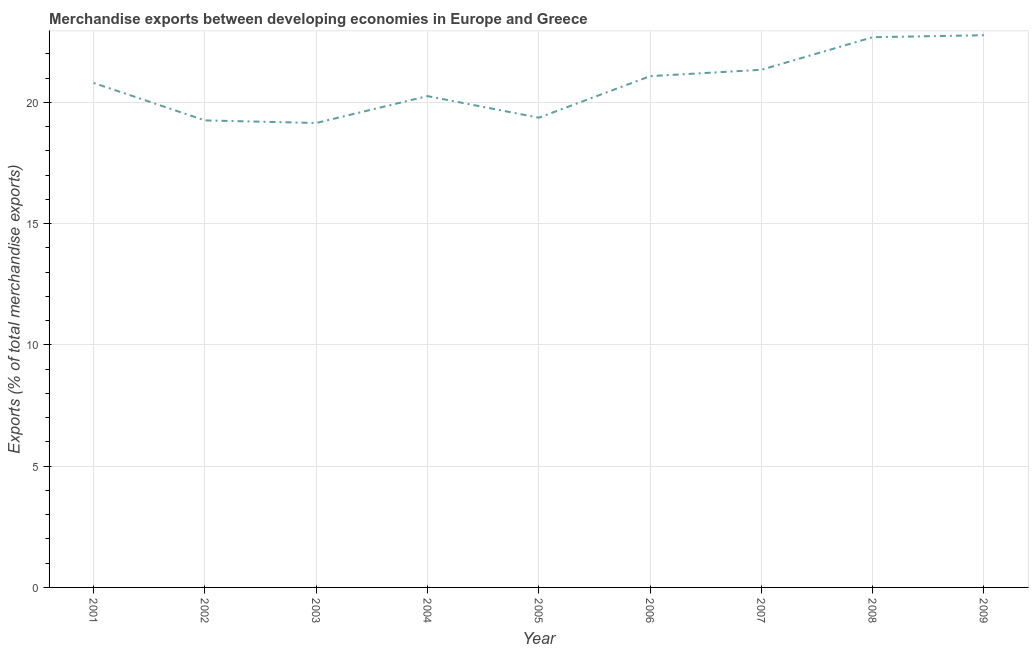What is the merchandise exports in 2008?
Keep it short and to the point. 22.68. Across all years, what is the maximum merchandise exports?
Offer a terse response. 22.77. Across all years, what is the minimum merchandise exports?
Offer a very short reply. 19.15. In which year was the merchandise exports minimum?
Ensure brevity in your answer.  2003. What is the sum of the merchandise exports?
Ensure brevity in your answer.  186.68. What is the difference between the merchandise exports in 2004 and 2009?
Your answer should be compact. -2.51. What is the average merchandise exports per year?
Keep it short and to the point. 20.74. What is the median merchandise exports?
Offer a very short reply. 20.8. In how many years, is the merchandise exports greater than 4 %?
Provide a short and direct response. 9. What is the ratio of the merchandise exports in 2005 to that in 2008?
Your answer should be compact. 0.85. Is the merchandise exports in 2006 less than that in 2009?
Provide a short and direct response. Yes. What is the difference between the highest and the second highest merchandise exports?
Provide a short and direct response. 0.08. What is the difference between the highest and the lowest merchandise exports?
Your response must be concise. 3.62. Does the merchandise exports monotonically increase over the years?
Provide a short and direct response. No. How many years are there in the graph?
Offer a very short reply. 9. Does the graph contain any zero values?
Ensure brevity in your answer.  No. Does the graph contain grids?
Ensure brevity in your answer.  Yes. What is the title of the graph?
Ensure brevity in your answer.  Merchandise exports between developing economies in Europe and Greece. What is the label or title of the Y-axis?
Keep it short and to the point. Exports (% of total merchandise exports). What is the Exports (% of total merchandise exports) in 2001?
Provide a succinct answer. 20.8. What is the Exports (% of total merchandise exports) in 2002?
Provide a short and direct response. 19.25. What is the Exports (% of total merchandise exports) in 2003?
Offer a very short reply. 19.15. What is the Exports (% of total merchandise exports) in 2004?
Your response must be concise. 20.25. What is the Exports (% of total merchandise exports) in 2005?
Offer a terse response. 19.36. What is the Exports (% of total merchandise exports) in 2006?
Offer a terse response. 21.08. What is the Exports (% of total merchandise exports) in 2007?
Provide a succinct answer. 21.34. What is the Exports (% of total merchandise exports) of 2008?
Offer a very short reply. 22.68. What is the Exports (% of total merchandise exports) of 2009?
Your answer should be very brief. 22.77. What is the difference between the Exports (% of total merchandise exports) in 2001 and 2002?
Offer a very short reply. 1.54. What is the difference between the Exports (% of total merchandise exports) in 2001 and 2003?
Offer a very short reply. 1.65. What is the difference between the Exports (% of total merchandise exports) in 2001 and 2004?
Provide a short and direct response. 0.54. What is the difference between the Exports (% of total merchandise exports) in 2001 and 2005?
Give a very brief answer. 1.43. What is the difference between the Exports (% of total merchandise exports) in 2001 and 2006?
Keep it short and to the point. -0.28. What is the difference between the Exports (% of total merchandise exports) in 2001 and 2007?
Keep it short and to the point. -0.54. What is the difference between the Exports (% of total merchandise exports) in 2001 and 2008?
Make the answer very short. -1.88. What is the difference between the Exports (% of total merchandise exports) in 2001 and 2009?
Your answer should be very brief. -1.97. What is the difference between the Exports (% of total merchandise exports) in 2002 and 2003?
Your response must be concise. 0.11. What is the difference between the Exports (% of total merchandise exports) in 2002 and 2004?
Offer a very short reply. -1. What is the difference between the Exports (% of total merchandise exports) in 2002 and 2005?
Keep it short and to the point. -0.11. What is the difference between the Exports (% of total merchandise exports) in 2002 and 2006?
Provide a succinct answer. -1.82. What is the difference between the Exports (% of total merchandise exports) in 2002 and 2007?
Your answer should be compact. -2.09. What is the difference between the Exports (% of total merchandise exports) in 2002 and 2008?
Make the answer very short. -3.43. What is the difference between the Exports (% of total merchandise exports) in 2002 and 2009?
Ensure brevity in your answer.  -3.51. What is the difference between the Exports (% of total merchandise exports) in 2003 and 2004?
Your answer should be compact. -1.11. What is the difference between the Exports (% of total merchandise exports) in 2003 and 2005?
Provide a succinct answer. -0.22. What is the difference between the Exports (% of total merchandise exports) in 2003 and 2006?
Provide a short and direct response. -1.93. What is the difference between the Exports (% of total merchandise exports) in 2003 and 2007?
Provide a succinct answer. -2.19. What is the difference between the Exports (% of total merchandise exports) in 2003 and 2008?
Provide a short and direct response. -3.54. What is the difference between the Exports (% of total merchandise exports) in 2003 and 2009?
Make the answer very short. -3.62. What is the difference between the Exports (% of total merchandise exports) in 2004 and 2005?
Your answer should be compact. 0.89. What is the difference between the Exports (% of total merchandise exports) in 2004 and 2006?
Keep it short and to the point. -0.82. What is the difference between the Exports (% of total merchandise exports) in 2004 and 2007?
Your answer should be very brief. -1.09. What is the difference between the Exports (% of total merchandise exports) in 2004 and 2008?
Keep it short and to the point. -2.43. What is the difference between the Exports (% of total merchandise exports) in 2004 and 2009?
Offer a terse response. -2.51. What is the difference between the Exports (% of total merchandise exports) in 2005 and 2006?
Keep it short and to the point. -1.71. What is the difference between the Exports (% of total merchandise exports) in 2005 and 2007?
Your answer should be compact. -1.98. What is the difference between the Exports (% of total merchandise exports) in 2005 and 2008?
Provide a short and direct response. -3.32. What is the difference between the Exports (% of total merchandise exports) in 2005 and 2009?
Make the answer very short. -3.4. What is the difference between the Exports (% of total merchandise exports) in 2006 and 2007?
Your response must be concise. -0.26. What is the difference between the Exports (% of total merchandise exports) in 2006 and 2008?
Offer a terse response. -1.61. What is the difference between the Exports (% of total merchandise exports) in 2006 and 2009?
Your response must be concise. -1.69. What is the difference between the Exports (% of total merchandise exports) in 2007 and 2008?
Ensure brevity in your answer.  -1.34. What is the difference between the Exports (% of total merchandise exports) in 2007 and 2009?
Your response must be concise. -1.42. What is the difference between the Exports (% of total merchandise exports) in 2008 and 2009?
Keep it short and to the point. -0.08. What is the ratio of the Exports (% of total merchandise exports) in 2001 to that in 2002?
Provide a short and direct response. 1.08. What is the ratio of the Exports (% of total merchandise exports) in 2001 to that in 2003?
Give a very brief answer. 1.09. What is the ratio of the Exports (% of total merchandise exports) in 2001 to that in 2004?
Offer a terse response. 1.03. What is the ratio of the Exports (% of total merchandise exports) in 2001 to that in 2005?
Ensure brevity in your answer.  1.07. What is the ratio of the Exports (% of total merchandise exports) in 2001 to that in 2006?
Keep it short and to the point. 0.99. What is the ratio of the Exports (% of total merchandise exports) in 2001 to that in 2007?
Provide a succinct answer. 0.97. What is the ratio of the Exports (% of total merchandise exports) in 2001 to that in 2008?
Offer a terse response. 0.92. What is the ratio of the Exports (% of total merchandise exports) in 2001 to that in 2009?
Offer a terse response. 0.91. What is the ratio of the Exports (% of total merchandise exports) in 2002 to that in 2004?
Provide a succinct answer. 0.95. What is the ratio of the Exports (% of total merchandise exports) in 2002 to that in 2007?
Offer a terse response. 0.9. What is the ratio of the Exports (% of total merchandise exports) in 2002 to that in 2008?
Give a very brief answer. 0.85. What is the ratio of the Exports (% of total merchandise exports) in 2002 to that in 2009?
Give a very brief answer. 0.85. What is the ratio of the Exports (% of total merchandise exports) in 2003 to that in 2004?
Make the answer very short. 0.94. What is the ratio of the Exports (% of total merchandise exports) in 2003 to that in 2006?
Ensure brevity in your answer.  0.91. What is the ratio of the Exports (% of total merchandise exports) in 2003 to that in 2007?
Your answer should be compact. 0.9. What is the ratio of the Exports (% of total merchandise exports) in 2003 to that in 2008?
Your answer should be compact. 0.84. What is the ratio of the Exports (% of total merchandise exports) in 2003 to that in 2009?
Offer a terse response. 0.84. What is the ratio of the Exports (% of total merchandise exports) in 2004 to that in 2005?
Your answer should be very brief. 1.05. What is the ratio of the Exports (% of total merchandise exports) in 2004 to that in 2007?
Your response must be concise. 0.95. What is the ratio of the Exports (% of total merchandise exports) in 2004 to that in 2008?
Your answer should be compact. 0.89. What is the ratio of the Exports (% of total merchandise exports) in 2004 to that in 2009?
Your answer should be compact. 0.89. What is the ratio of the Exports (% of total merchandise exports) in 2005 to that in 2006?
Offer a terse response. 0.92. What is the ratio of the Exports (% of total merchandise exports) in 2005 to that in 2007?
Your response must be concise. 0.91. What is the ratio of the Exports (% of total merchandise exports) in 2005 to that in 2008?
Provide a succinct answer. 0.85. What is the ratio of the Exports (% of total merchandise exports) in 2005 to that in 2009?
Give a very brief answer. 0.85. What is the ratio of the Exports (% of total merchandise exports) in 2006 to that in 2008?
Provide a succinct answer. 0.93. What is the ratio of the Exports (% of total merchandise exports) in 2006 to that in 2009?
Offer a terse response. 0.93. What is the ratio of the Exports (% of total merchandise exports) in 2007 to that in 2008?
Your response must be concise. 0.94. What is the ratio of the Exports (% of total merchandise exports) in 2007 to that in 2009?
Provide a succinct answer. 0.94. 